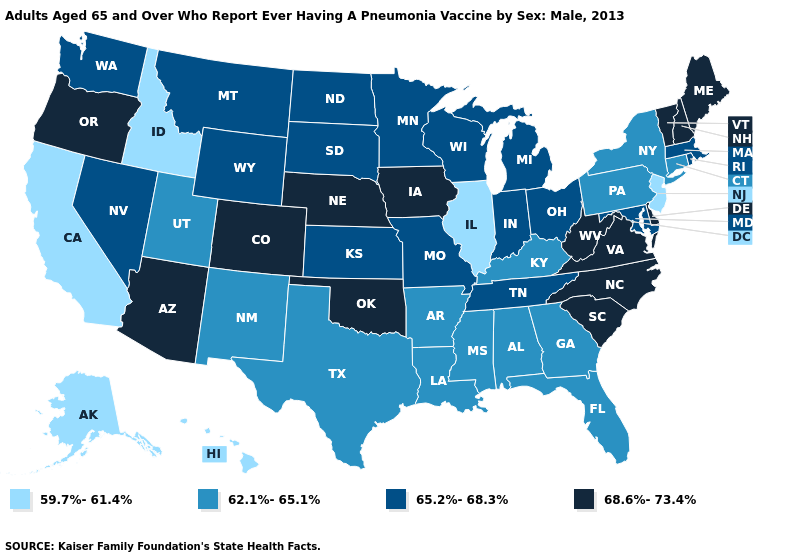Name the states that have a value in the range 59.7%-61.4%?
Quick response, please. Alaska, California, Hawaii, Idaho, Illinois, New Jersey. Does Idaho have the lowest value in the USA?
Concise answer only. Yes. Does the map have missing data?
Keep it brief. No. Name the states that have a value in the range 59.7%-61.4%?
Be succinct. Alaska, California, Hawaii, Idaho, Illinois, New Jersey. Name the states that have a value in the range 68.6%-73.4%?
Keep it brief. Arizona, Colorado, Delaware, Iowa, Maine, Nebraska, New Hampshire, North Carolina, Oklahoma, Oregon, South Carolina, Vermont, Virginia, West Virginia. Name the states that have a value in the range 65.2%-68.3%?
Short answer required. Indiana, Kansas, Maryland, Massachusetts, Michigan, Minnesota, Missouri, Montana, Nevada, North Dakota, Ohio, Rhode Island, South Dakota, Tennessee, Washington, Wisconsin, Wyoming. Does Colorado have the highest value in the West?
Answer briefly. Yes. Which states have the highest value in the USA?
Quick response, please. Arizona, Colorado, Delaware, Iowa, Maine, Nebraska, New Hampshire, North Carolina, Oklahoma, Oregon, South Carolina, Vermont, Virginia, West Virginia. What is the value of Indiana?
Keep it brief. 65.2%-68.3%. Among the states that border Arkansas , which have the highest value?
Answer briefly. Oklahoma. What is the lowest value in states that border Arkansas?
Be succinct. 62.1%-65.1%. What is the lowest value in states that border Kentucky?
Write a very short answer. 59.7%-61.4%. Name the states that have a value in the range 65.2%-68.3%?
Concise answer only. Indiana, Kansas, Maryland, Massachusetts, Michigan, Minnesota, Missouri, Montana, Nevada, North Dakota, Ohio, Rhode Island, South Dakota, Tennessee, Washington, Wisconsin, Wyoming. What is the value of Wyoming?
Short answer required. 65.2%-68.3%. Does Nebraska have the highest value in the MidWest?
Quick response, please. Yes. 